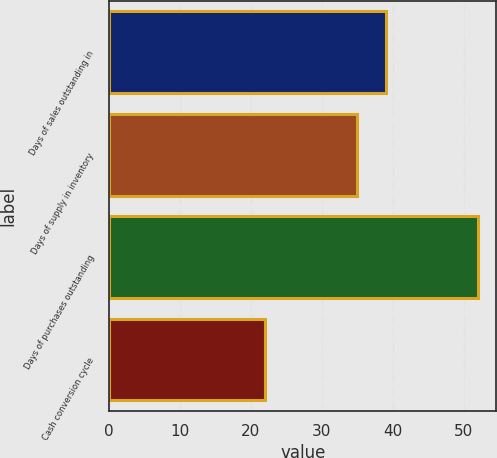Convert chart. <chart><loc_0><loc_0><loc_500><loc_500><bar_chart><fcel>Days of sales outstanding in<fcel>Days of supply in inventory<fcel>Days of purchases outstanding<fcel>Cash conversion cycle<nl><fcel>39<fcel>35<fcel>52<fcel>22<nl></chart> 